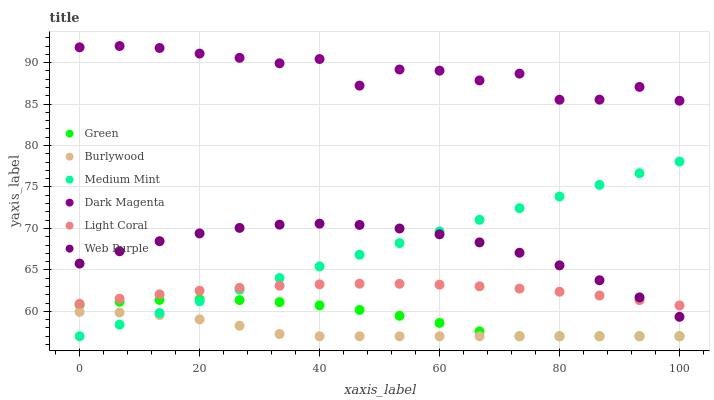Does Burlywood have the minimum area under the curve?
Answer yes or no. Yes. Does Dark Magenta have the maximum area under the curve?
Answer yes or no. Yes. Does Dark Magenta have the minimum area under the curve?
Answer yes or no. No. Does Burlywood have the maximum area under the curve?
Answer yes or no. No. Is Medium Mint the smoothest?
Answer yes or no. Yes. Is Dark Magenta the roughest?
Answer yes or no. Yes. Is Burlywood the smoothest?
Answer yes or no. No. Is Burlywood the roughest?
Answer yes or no. No. Does Medium Mint have the lowest value?
Answer yes or no. Yes. Does Dark Magenta have the lowest value?
Answer yes or no. No. Does Dark Magenta have the highest value?
Answer yes or no. Yes. Does Burlywood have the highest value?
Answer yes or no. No. Is Burlywood less than Dark Magenta?
Answer yes or no. Yes. Is Dark Magenta greater than Green?
Answer yes or no. Yes. Does Burlywood intersect Green?
Answer yes or no. Yes. Is Burlywood less than Green?
Answer yes or no. No. Is Burlywood greater than Green?
Answer yes or no. No. Does Burlywood intersect Dark Magenta?
Answer yes or no. No. 